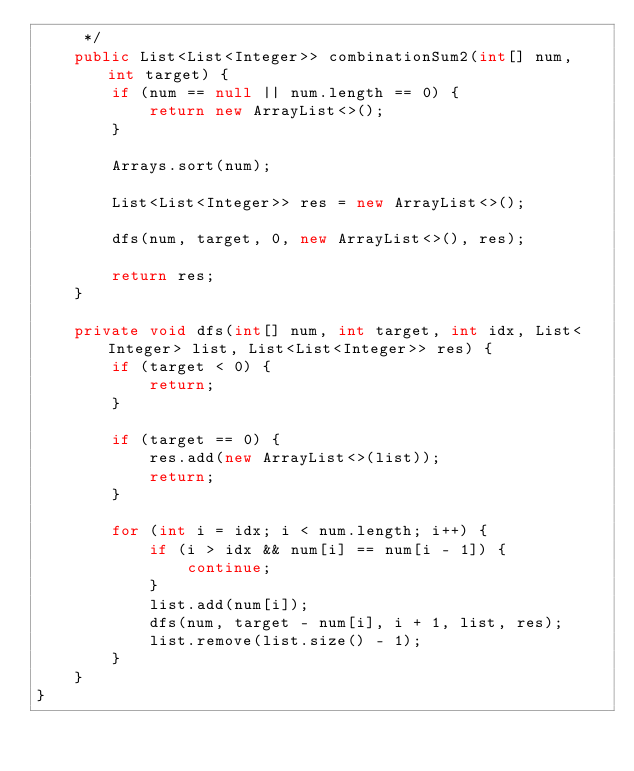Convert code to text. <code><loc_0><loc_0><loc_500><loc_500><_Java_>     */
    public List<List<Integer>> combinationSum2(int[] num, int target) {
        if (num == null || num.length == 0) {
            return new ArrayList<>();
        }
        
        Arrays.sort(num);
        
        List<List<Integer>> res = new ArrayList<>();
        
        dfs(num, target, 0, new ArrayList<>(), res);
        
        return res;
    }
    
    private void dfs(int[] num, int target, int idx, List<Integer> list, List<List<Integer>> res) {
        if (target < 0) {
            return;
        }
        
        if (target == 0) {
            res.add(new ArrayList<>(list));
            return;
        }
        
        for (int i = idx; i < num.length; i++) {
            if (i > idx && num[i] == num[i - 1]) {
                continue;
            }
            list.add(num[i]);
            dfs(num, target - num[i], i + 1, list, res);
            list.remove(list.size() - 1);
        }
    }
}</code> 